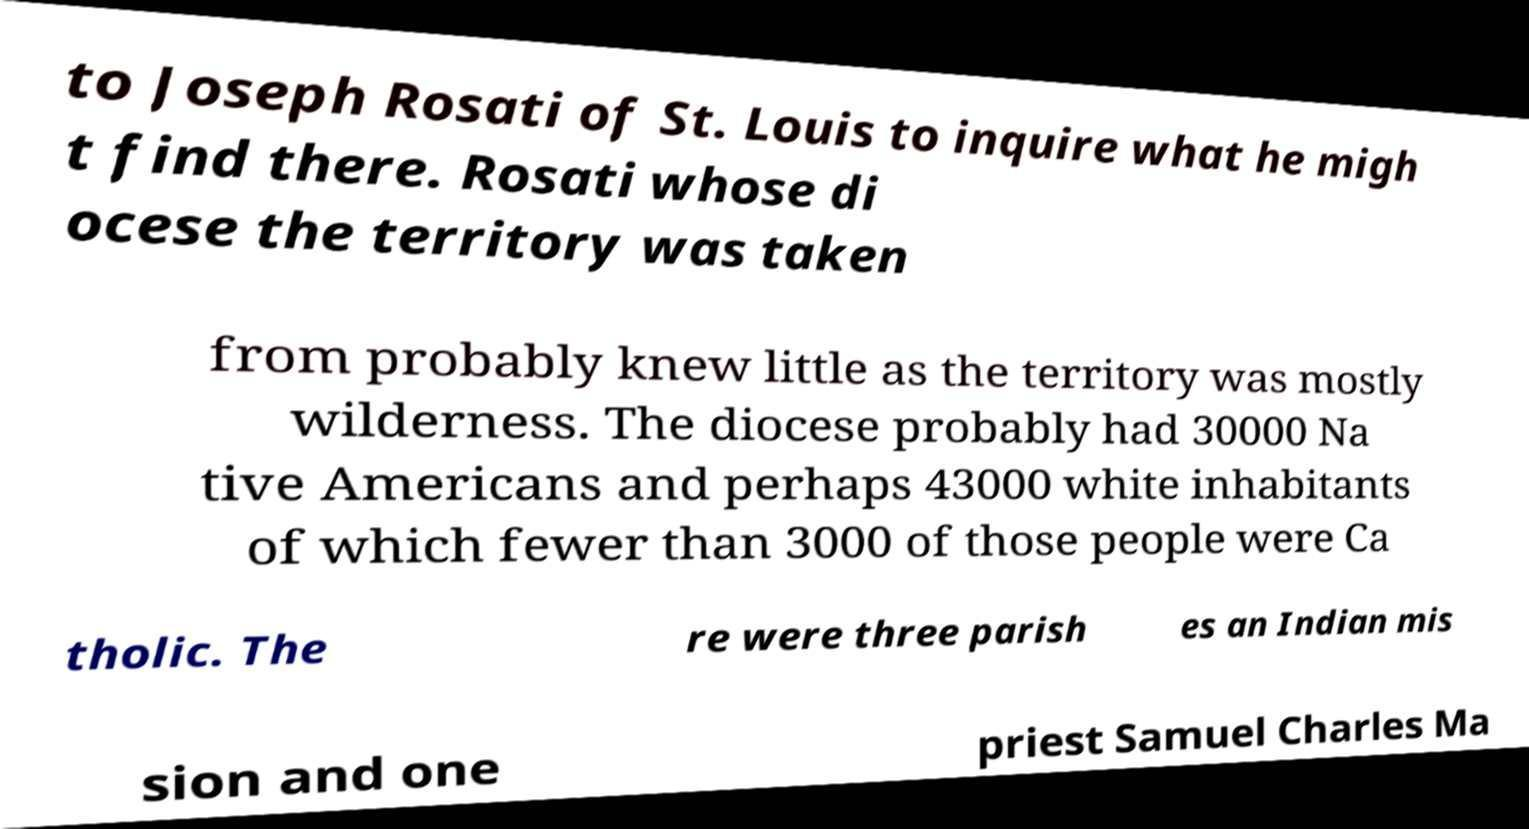Can you read and provide the text displayed in the image?This photo seems to have some interesting text. Can you extract and type it out for me? to Joseph Rosati of St. Louis to inquire what he migh t find there. Rosati whose di ocese the territory was taken from probably knew little as the territory was mostly wilderness. The diocese probably had 30000 Na tive Americans and perhaps 43000 white inhabitants of which fewer than 3000 of those people were Ca tholic. The re were three parish es an Indian mis sion and one priest Samuel Charles Ma 